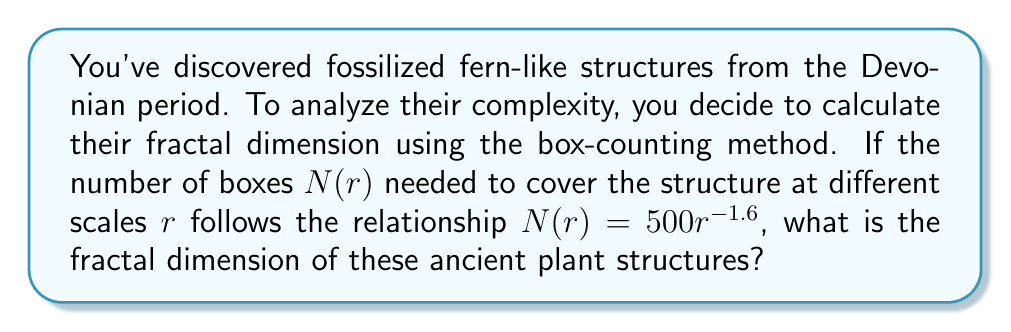Give your solution to this math problem. To solve this problem, we'll use the box-counting method for calculating fractal dimension. The fractal dimension $D$ is given by the relationship:

$$N(r) = cr^{-D}$$

where $N(r)$ is the number of boxes needed to cover the structure at scale $r$, $c$ is a constant, and $D$ is the fractal dimension.

In our case, we're given:

$$N(r) = 500r^{-1.6}$$

Comparing this to the general form, we can see that:
$c = 500$
$D = 1.6$

The fractal dimension is the exponent in this relationship, so the fractal dimension of the ancient plant structures is 1.6.

This value between 1 and 2 indicates that the structure is more complex than a simple line (dimension 1) but doesn't completely fill a 2D plane. This is typical for many natural structures, including ferns and other plants, which often exhibit self-similarity across different scales.

For paleobotanists, this fractal dimension can provide insights into the complexity and growth patterns of ancient plants, helping to understand their adaptation to the Devonian environment and their relationship to modern plant species.
Answer: The fractal dimension of the ancient plant structures is 1.6. 